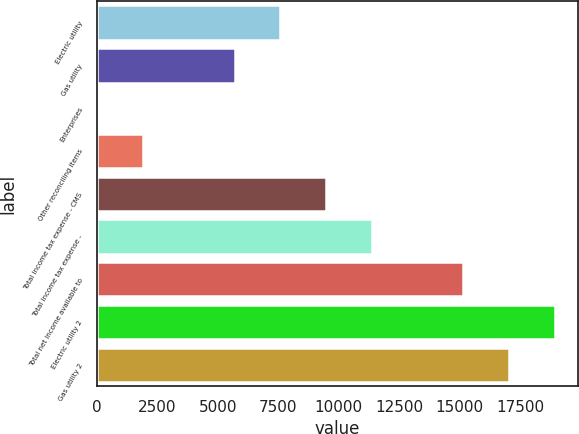Convert chart to OTSL. <chart><loc_0><loc_0><loc_500><loc_500><bar_chart><fcel>Electric utility<fcel>Gas utility<fcel>Enterprises<fcel>Other reconciling items<fcel>Total income tax expense - CMS<fcel>Total income tax expense -<fcel>Total net income available to<fcel>Electric utility 2<fcel>Gas utility 2<nl><fcel>7579<fcel>5685<fcel>3<fcel>1897<fcel>9473<fcel>11367<fcel>15155<fcel>18943<fcel>17049<nl></chart> 